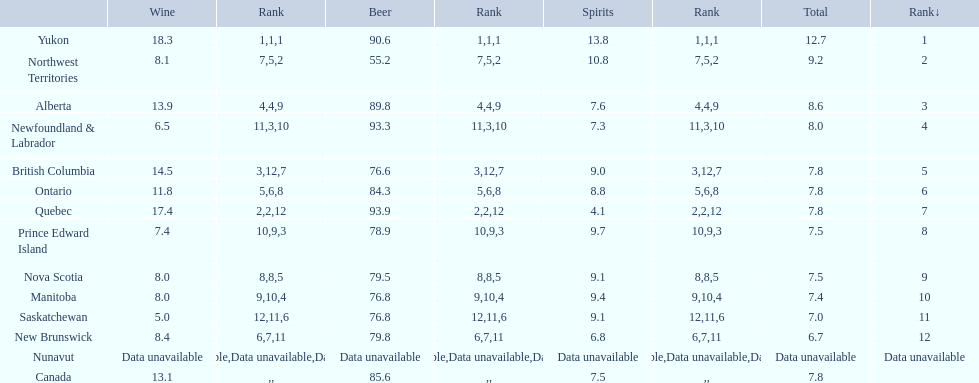What is the quantity of territories with a wine consumption surpassing 1 5. 